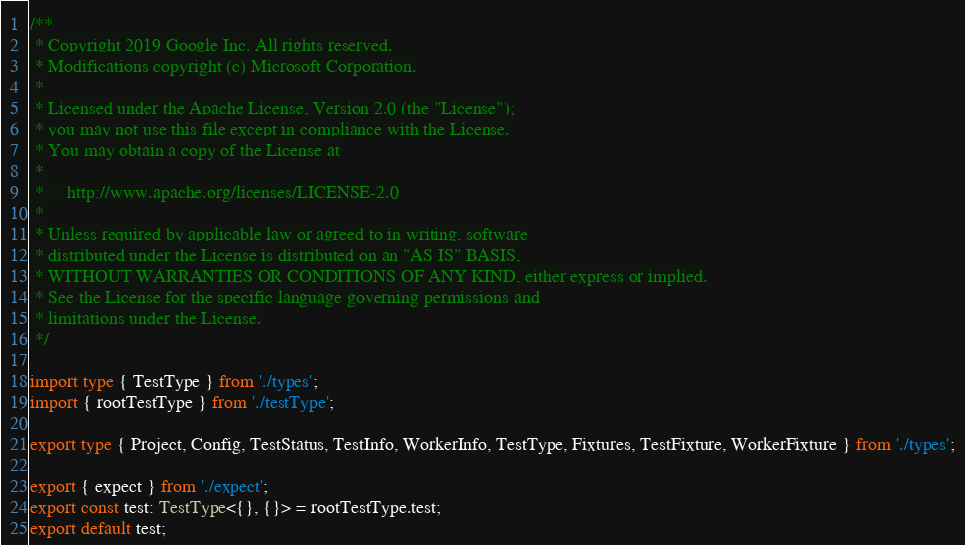<code> <loc_0><loc_0><loc_500><loc_500><_TypeScript_>/**
 * Copyright 2019 Google Inc. All rights reserved.
 * Modifications copyright (c) Microsoft Corporation.
 *
 * Licensed under the Apache License, Version 2.0 (the "License");
 * you may not use this file except in compliance with the License.
 * You may obtain a copy of the License at
 *
 *     http://www.apache.org/licenses/LICENSE-2.0
 *
 * Unless required by applicable law or agreed to in writing, software
 * distributed under the License is distributed on an "AS IS" BASIS,
 * WITHOUT WARRANTIES OR CONDITIONS OF ANY KIND, either express or implied.
 * See the License for the specific language governing permissions and
 * limitations under the License.
 */

import type { TestType } from './types';
import { rootTestType } from './testType';

export type { Project, Config, TestStatus, TestInfo, WorkerInfo, TestType, Fixtures, TestFixture, WorkerFixture } from './types';

export { expect } from './expect';
export const test: TestType<{}, {}> = rootTestType.test;
export default test;
</code> 